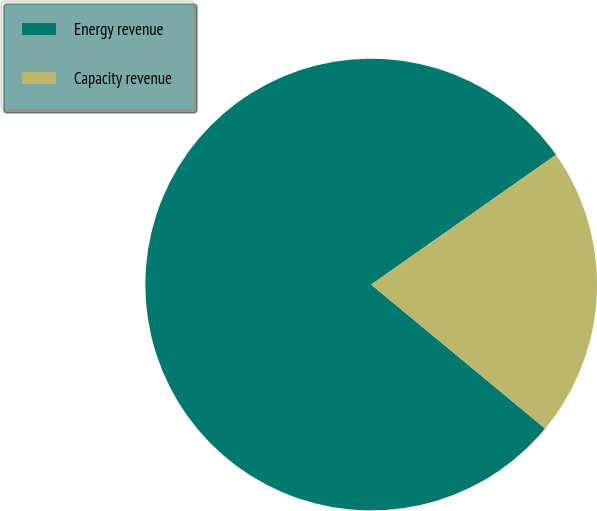<chart> <loc_0><loc_0><loc_500><loc_500><pie_chart><fcel>Energy revenue<fcel>Capacity revenue<nl><fcel>79.25%<fcel>20.75%<nl></chart> 